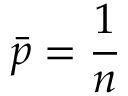<formula> <loc_0><loc_0><loc_500><loc_500>\bar { p } = \frac { 1 } { n }</formula> 